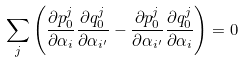Convert formula to latex. <formula><loc_0><loc_0><loc_500><loc_500>\sum _ { j } \left ( \frac { \partial p _ { 0 } ^ { j } } { \partial \alpha _ { i } } \frac { \partial q _ { 0 } ^ { j } } { \partial \alpha _ { i ^ { \prime } } } - \frac { \partial p _ { 0 } ^ { j } } { \partial \alpha _ { i ^ { \prime } } } \frac { \partial q _ { 0 } ^ { j } } { \partial \alpha _ { i } } \right ) = 0</formula> 